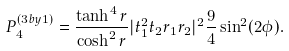Convert formula to latex. <formula><loc_0><loc_0><loc_500><loc_500>P _ { 4 } ^ { ( 3 b y 1 ) } = \frac { \tanh ^ { 4 } r } { \cosh ^ { 2 } r } | t _ { 1 } ^ { 2 } t _ { 2 } r _ { 1 } r _ { 2 } | ^ { 2 } \frac { 9 } { 4 } \sin ^ { 2 } ( 2 \phi ) .</formula> 